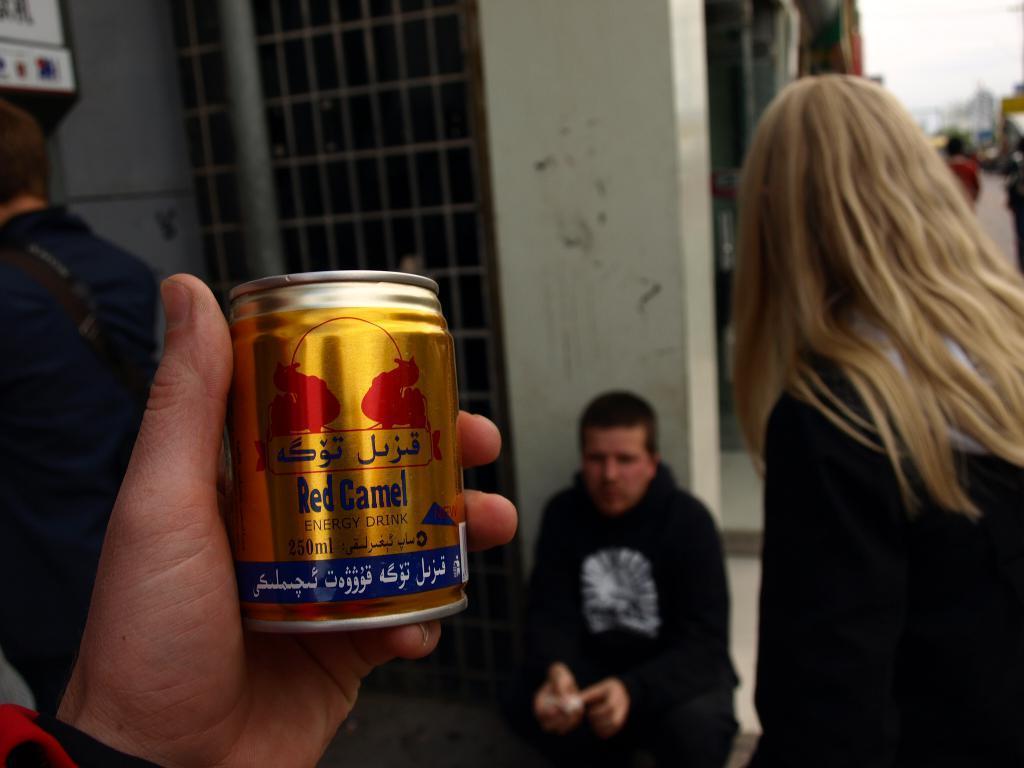Please provide a concise description of this image. In this image I can see a person is holding something. Back I can see few people and few objects. Background is blurred. 